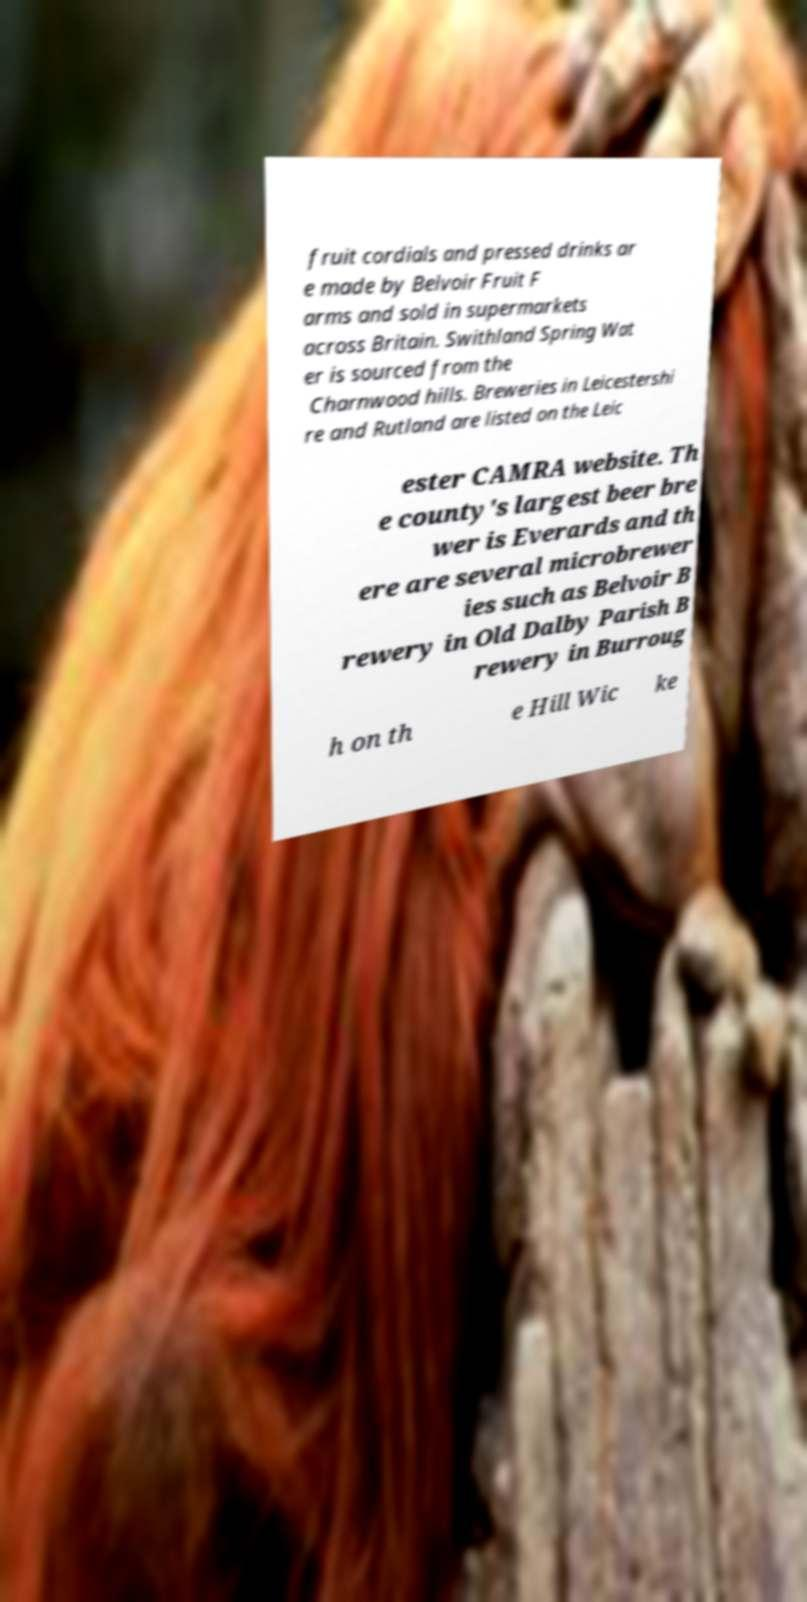Could you extract and type out the text from this image? fruit cordials and pressed drinks ar e made by Belvoir Fruit F arms and sold in supermarkets across Britain. Swithland Spring Wat er is sourced from the Charnwood hills. Breweries in Leicestershi re and Rutland are listed on the Leic ester CAMRA website. Th e county's largest beer bre wer is Everards and th ere are several microbrewer ies such as Belvoir B rewery in Old Dalby Parish B rewery in Burroug h on th e Hill Wic ke 